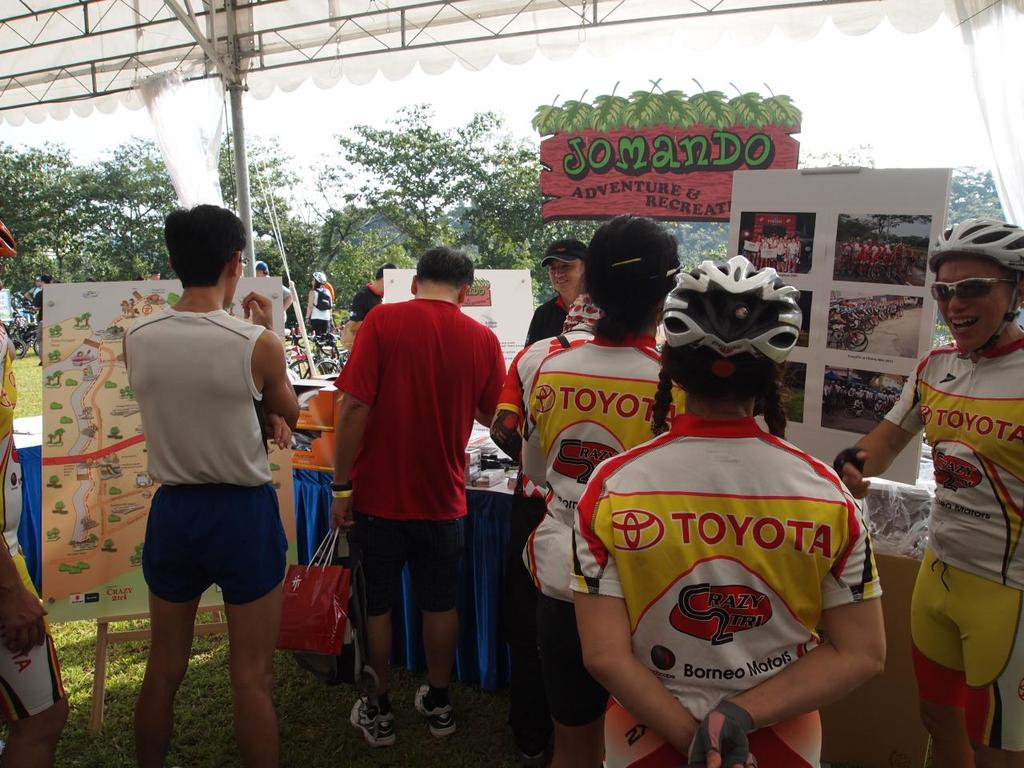Provide a one-sentence caption for the provided image. Cyclists dressed in bright yellow and red uniforms featuring a Toyota logo gather around a booth adorned with a 'Somando Adventure & Recreation' banner and an event map during an outdoor sports event. 